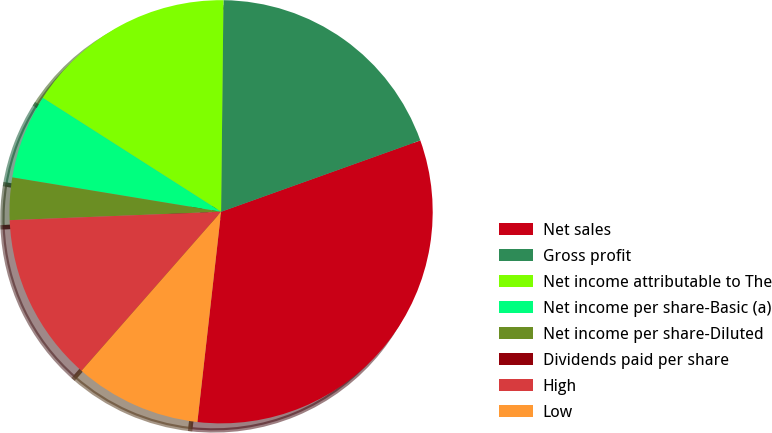Convert chart. <chart><loc_0><loc_0><loc_500><loc_500><pie_chart><fcel>Net sales<fcel>Gross profit<fcel>Net income attributable to The<fcel>Net income per share-Basic (a)<fcel>Net income per share-Diluted<fcel>Dividends paid per share<fcel>High<fcel>Low<nl><fcel>32.26%<fcel>19.35%<fcel>16.13%<fcel>6.45%<fcel>3.23%<fcel>0.0%<fcel>12.9%<fcel>9.68%<nl></chart> 